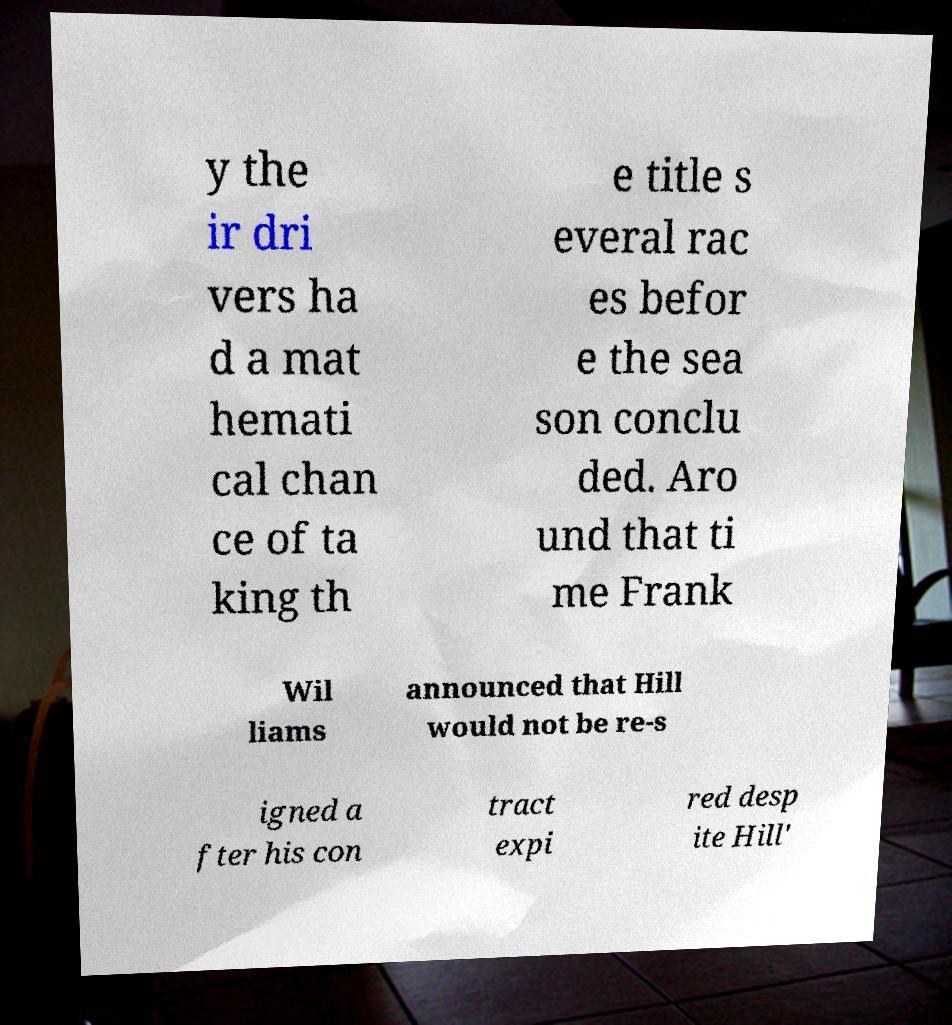Can you accurately transcribe the text from the provided image for me? y the ir dri vers ha d a mat hemati cal chan ce of ta king th e title s everal rac es befor e the sea son conclu ded. Aro und that ti me Frank Wil liams announced that Hill would not be re-s igned a fter his con tract expi red desp ite Hill' 